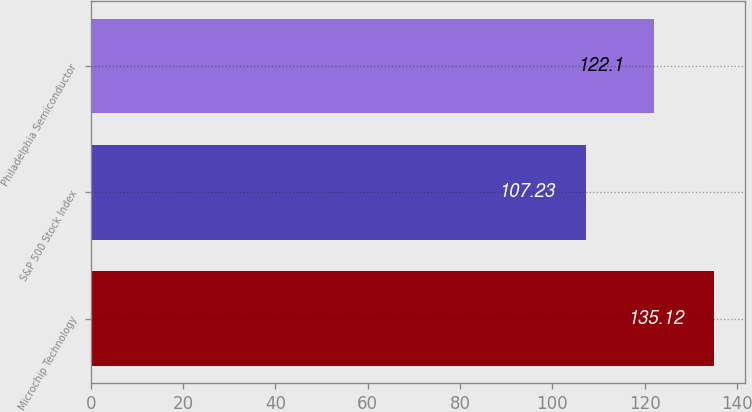Convert chart. <chart><loc_0><loc_0><loc_500><loc_500><bar_chart><fcel>Microchip Technology<fcel>S&P 500 Stock Index<fcel>Philadelphia Semiconductor<nl><fcel>135.12<fcel>107.23<fcel>122.1<nl></chart> 